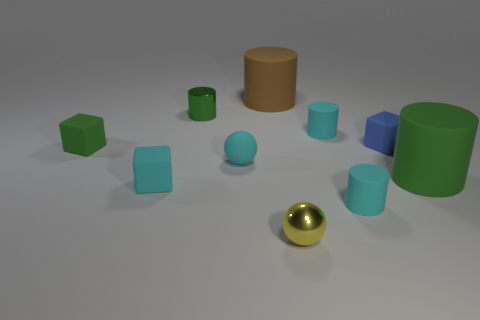Are there any large objects that have the same color as the tiny matte sphere? I've analyzed the image carefully, and there are no large objects sharing the same color as the tiny matte gold-colored sphere. Every other object in the scene presents a distinct hue, including various shades of green, blue, and one object in a pastel orange, creating a visually diverse array. 